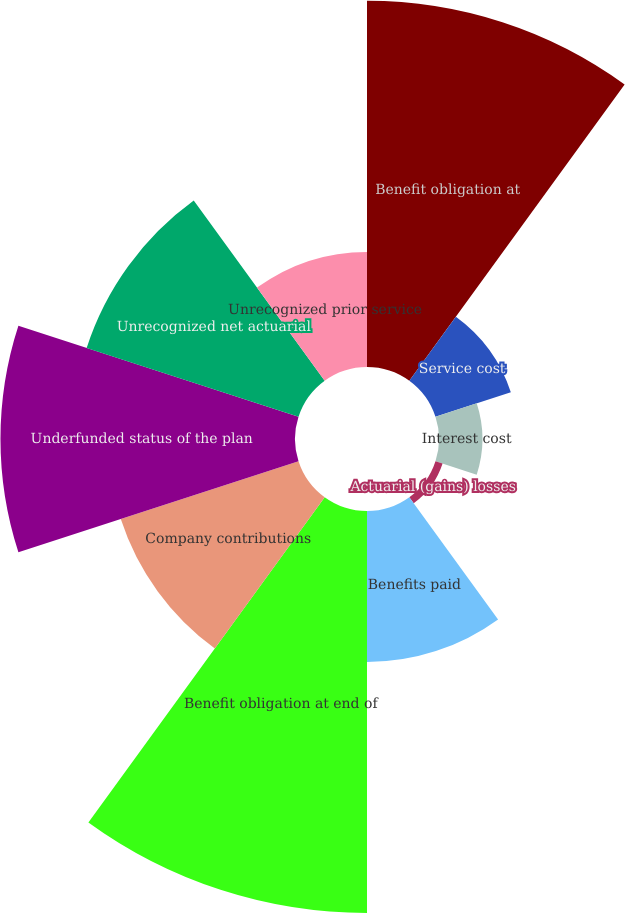Convert chart to OTSL. <chart><loc_0><loc_0><loc_500><loc_500><pie_chart><fcel>Benefit obligation at<fcel>Service cost<fcel>Interest cost<fcel>Actuarial (gains) losses<fcel>Benefits paid<fcel>Benefit obligation at end of<fcel>Company contributions<fcel>Underfunded status of the plan<fcel>Unrecognized net actuarial<fcel>Unrecognized prior service<nl><fcel>19.6%<fcel>4.24%<fcel>2.32%<fcel>0.4%<fcel>8.08%<fcel>21.51%<fcel>10.0%<fcel>15.76%<fcel>11.92%<fcel>6.16%<nl></chart> 